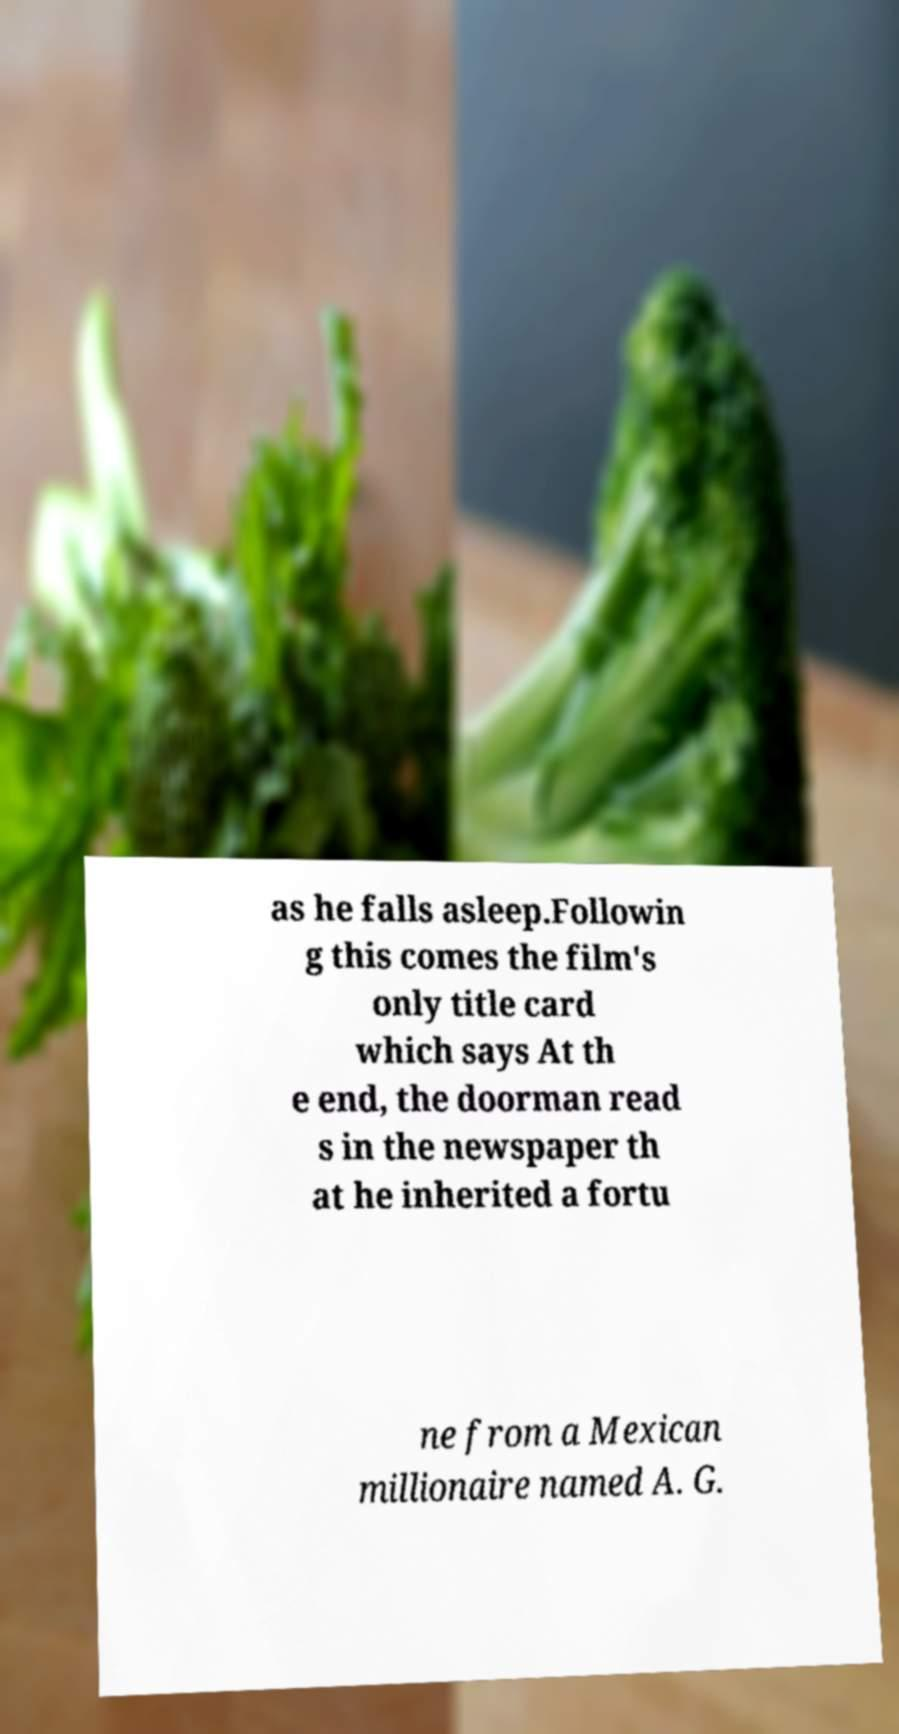There's text embedded in this image that I need extracted. Can you transcribe it verbatim? as he falls asleep.Followin g this comes the film's only title card which says At th e end, the doorman read s in the newspaper th at he inherited a fortu ne from a Mexican millionaire named A. G. 